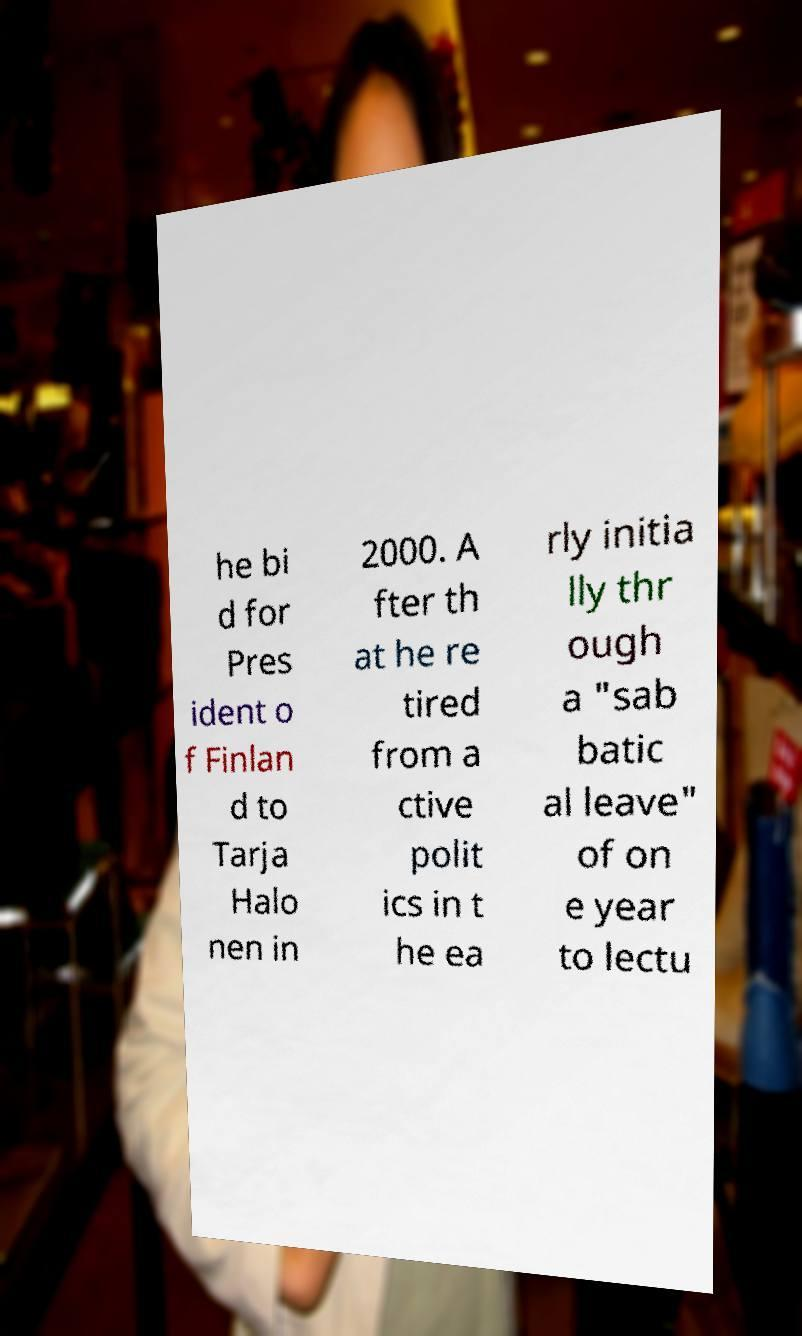For documentation purposes, I need the text within this image transcribed. Could you provide that? he bi d for Pres ident o f Finlan d to Tarja Halo nen in 2000. A fter th at he re tired from a ctive polit ics in t he ea rly initia lly thr ough a "sab batic al leave" of on e year to lectu 